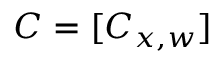Convert formula to latex. <formula><loc_0><loc_0><loc_500><loc_500>C = [ C _ { x , w } ]</formula> 